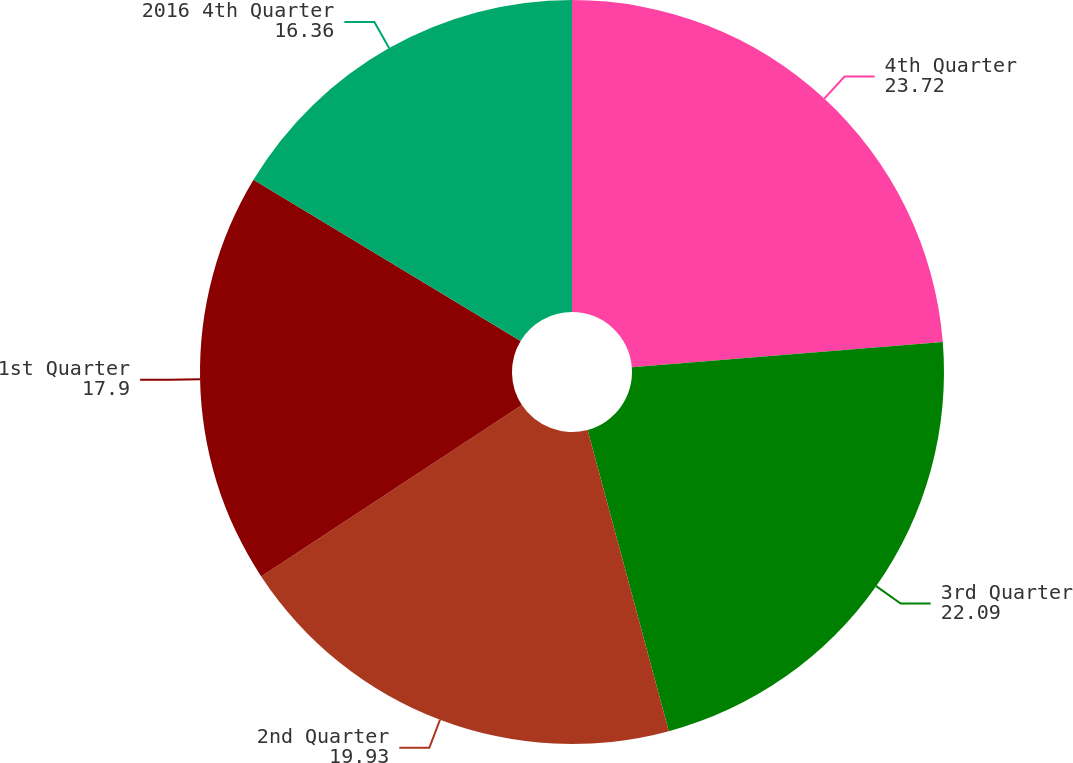Convert chart. <chart><loc_0><loc_0><loc_500><loc_500><pie_chart><fcel>4th Quarter<fcel>3rd Quarter<fcel>2nd Quarter<fcel>1st Quarter<fcel>2016 4th Quarter<nl><fcel>23.72%<fcel>22.09%<fcel>19.93%<fcel>17.9%<fcel>16.36%<nl></chart> 